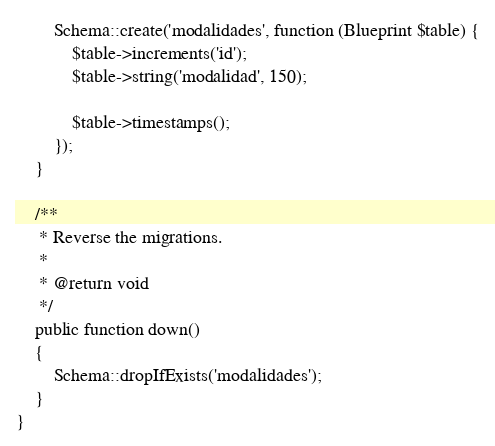<code> <loc_0><loc_0><loc_500><loc_500><_PHP_>        Schema::create('modalidades', function (Blueprint $table) {
            $table->increments('id');
            $table->string('modalidad', 150);

            $table->timestamps();
        });
    }

    /**
     * Reverse the migrations.
     *
     * @return void
     */
    public function down()
    {
        Schema::dropIfExists('modalidades');
    }
}
</code> 